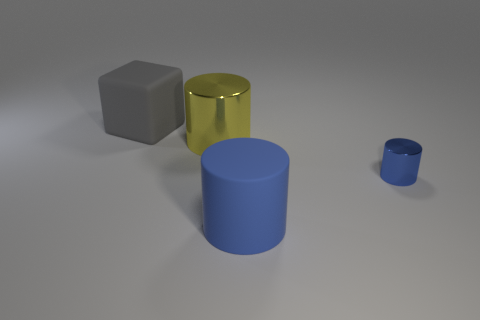How many shiny things are cubes or tiny objects?
Give a very brief answer. 1. There is a large shiny object; what shape is it?
Offer a terse response. Cylinder. What number of blue cylinders are the same material as the yellow cylinder?
Your answer should be compact. 1. There is a large cylinder that is made of the same material as the large gray cube; what is its color?
Provide a short and direct response. Blue. There is a metallic object in front of the yellow object; does it have the same size as the yellow metallic object?
Give a very brief answer. No. What color is the large matte thing that is the same shape as the small blue thing?
Your answer should be very brief. Blue. There is a matte thing left of the object in front of the metallic thing right of the large blue rubber thing; what is its shape?
Make the answer very short. Cube. Is the shape of the big blue object the same as the small blue metallic object?
Give a very brief answer. Yes. There is a blue thing that is on the right side of the matte object that is on the right side of the gray block; what shape is it?
Your answer should be very brief. Cylinder. Is there a large purple rubber cylinder?
Offer a very short reply. No. 